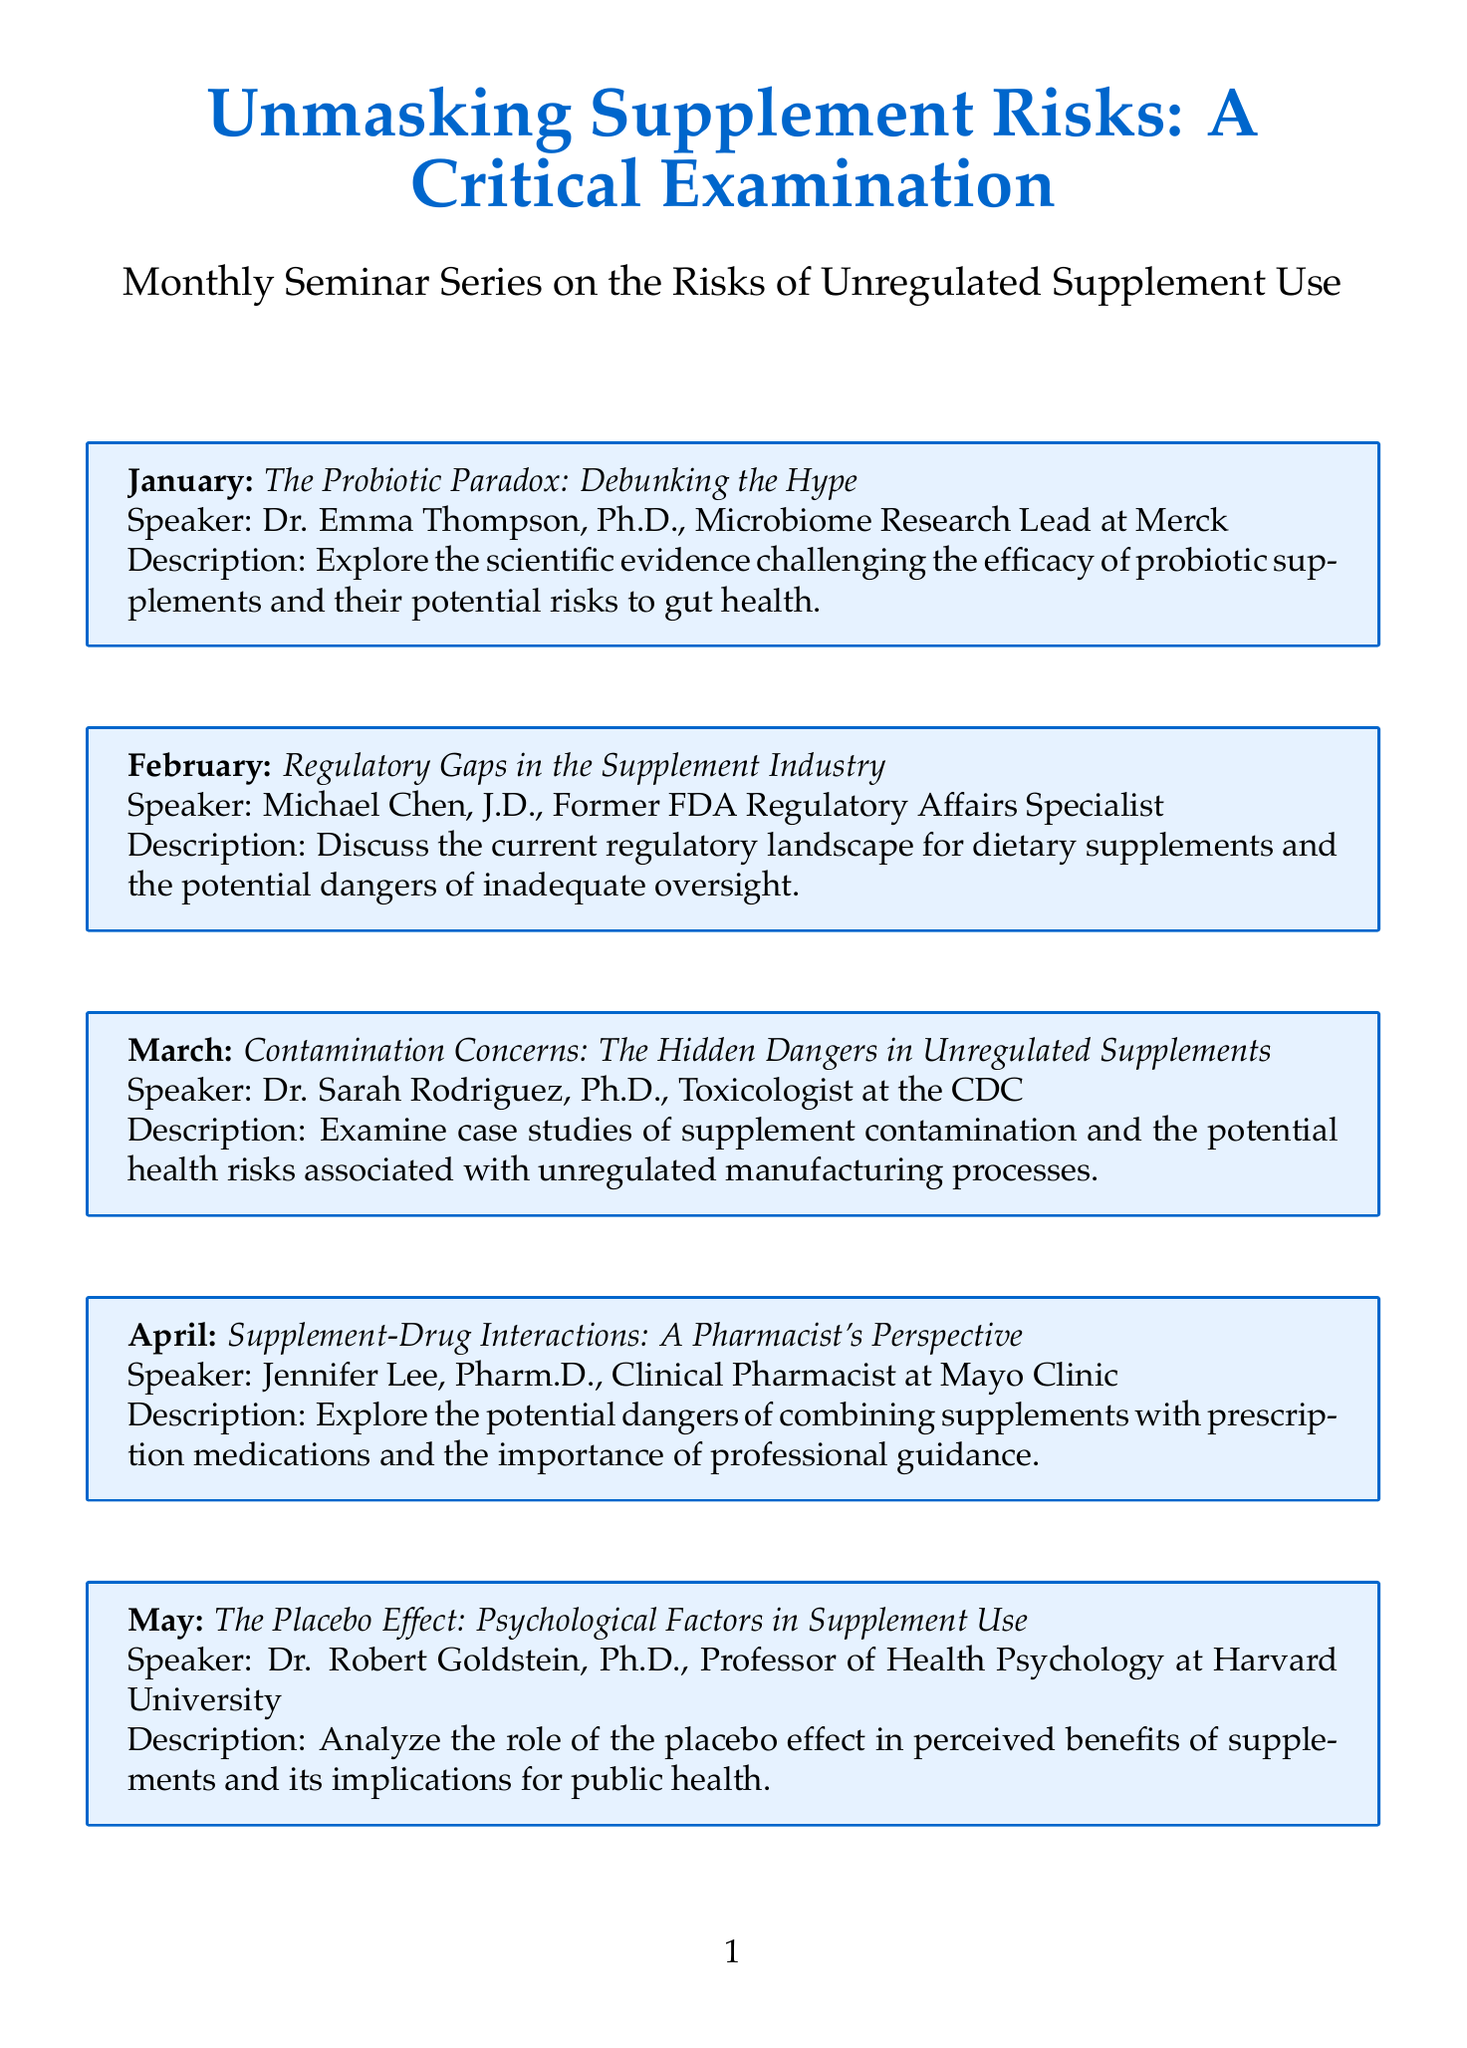What is the title of the seminar series? The title is explicitly stated at the beginning of the document as "Unmasking Supplement Risks: A Critical Examination."
Answer: Unmasking Supplement Risks: A Critical Examination Who is the speaker for the February session? The document lists the speaker for February as Michael Chen, who is a Former FDA Regulatory Affairs Specialist.
Answer: Michael Chen, J.D What is the topic for the March session? The document clearly states that the topic for March is "Contamination Concerns: The Hidden Dangers in Unregulated Supplements."
Answer: Contamination Concerns: The Hidden Dangers in Unregulated Supplements Which month features a discussion on the placebo effect? The month dedicated to discussing the placebo effect is May, as mentioned in the respective section title.
Answer: May How many sessions are focused on probiotics? There are two sessions specifically addressing probiotics, one in January and one in November.
Answer: Two What is the main focus of the November session? The document describes the November session focus as "The Microbiome Revolution: Why Probiotics Fall Short."
Answer: The Microbiome Revolution: Why Probiotics Fall Short Who is the speaker for the session on herbal supplements? The document identifies Dr. Maria Gonzalez as the speaker for the September session on herbal supplements.
Answer: Dr. Maria Gonzalez, Ph.D What potential health aspect is discussed in the April session? The April session addresses the potential dangers of combining supplements with prescription medications.
Answer: Supplement-Drug Interactions Which month includes a discussion about policy recommendations? The document shows that the month focusing on policy recommendations is December.
Answer: December 